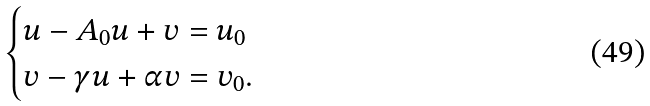<formula> <loc_0><loc_0><loc_500><loc_500>\begin{cases} u - A _ { 0 } u + v = u _ { 0 } \\ v - \gamma u + \alpha v = v _ { 0 } . \end{cases}</formula> 